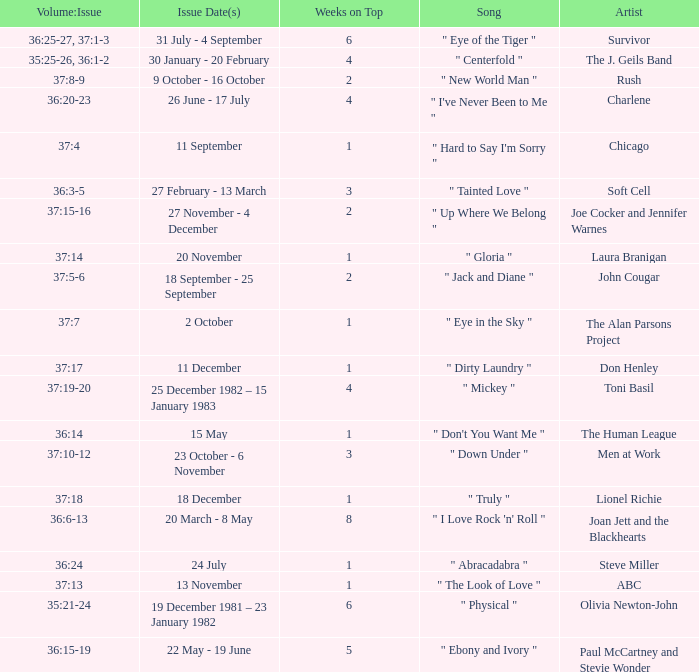Which Issue Date(s) has Weeks on Top larger than 3, and a Volume: Issue of 35:25-26, 36:1-2? 30 January - 20 February. 